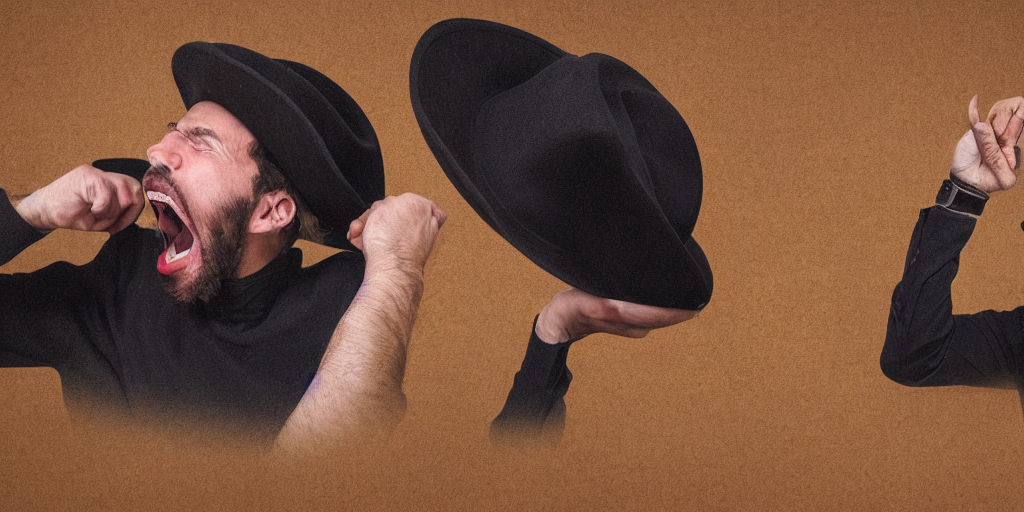How might this image be used in media or advertising? This striking image could be effectively used in campaigns that emphasize strong human emotions or the concept of 'a louder voice.' It could also be applied to contexts that deal with mental health, personal growth, or the multiplicity of human identity, possibly for promoting discussions, services, or artistic events. 